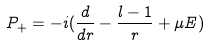<formula> <loc_0><loc_0><loc_500><loc_500>P _ { + } = - i ( \frac { d } { d r } - \frac { l - 1 } { r } + \mu E )</formula> 